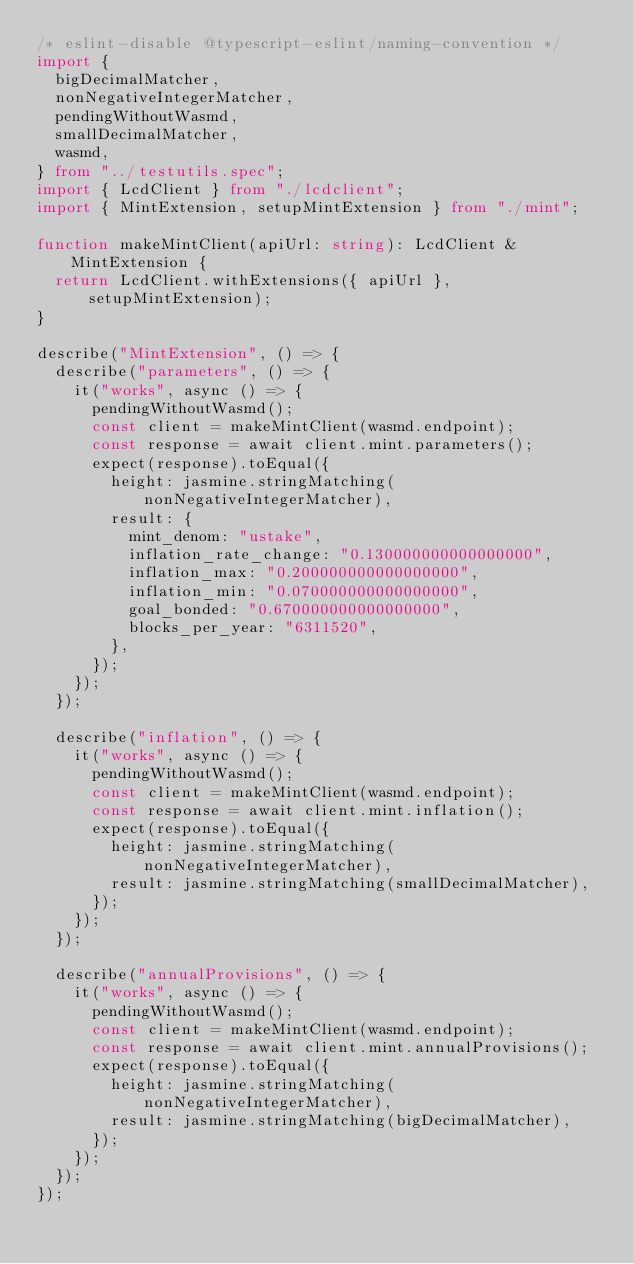Convert code to text. <code><loc_0><loc_0><loc_500><loc_500><_TypeScript_>/* eslint-disable @typescript-eslint/naming-convention */
import {
  bigDecimalMatcher,
  nonNegativeIntegerMatcher,
  pendingWithoutWasmd,
  smallDecimalMatcher,
  wasmd,
} from "../testutils.spec";
import { LcdClient } from "./lcdclient";
import { MintExtension, setupMintExtension } from "./mint";

function makeMintClient(apiUrl: string): LcdClient & MintExtension {
  return LcdClient.withExtensions({ apiUrl }, setupMintExtension);
}

describe("MintExtension", () => {
  describe("parameters", () => {
    it("works", async () => {
      pendingWithoutWasmd();
      const client = makeMintClient(wasmd.endpoint);
      const response = await client.mint.parameters();
      expect(response).toEqual({
        height: jasmine.stringMatching(nonNegativeIntegerMatcher),
        result: {
          mint_denom: "ustake",
          inflation_rate_change: "0.130000000000000000",
          inflation_max: "0.200000000000000000",
          inflation_min: "0.070000000000000000",
          goal_bonded: "0.670000000000000000",
          blocks_per_year: "6311520",
        },
      });
    });
  });

  describe("inflation", () => {
    it("works", async () => {
      pendingWithoutWasmd();
      const client = makeMintClient(wasmd.endpoint);
      const response = await client.mint.inflation();
      expect(response).toEqual({
        height: jasmine.stringMatching(nonNegativeIntegerMatcher),
        result: jasmine.stringMatching(smallDecimalMatcher),
      });
    });
  });

  describe("annualProvisions", () => {
    it("works", async () => {
      pendingWithoutWasmd();
      const client = makeMintClient(wasmd.endpoint);
      const response = await client.mint.annualProvisions();
      expect(response).toEqual({
        height: jasmine.stringMatching(nonNegativeIntegerMatcher),
        result: jasmine.stringMatching(bigDecimalMatcher),
      });
    });
  });
});
</code> 